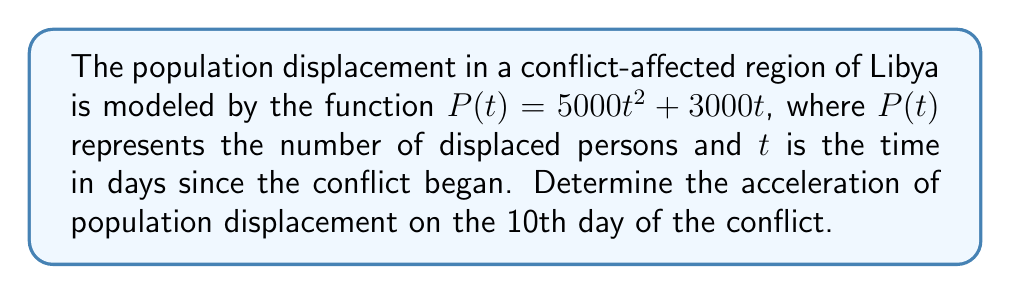Teach me how to tackle this problem. To find the acceleration of population displacement, we need to calculate the second derivative of the given function $P(t)$.

Step 1: Find the first derivative (velocity of displacement)
The first derivative represents the rate of change of displacement with respect to time:
$$P'(t) = \frac{d}{dt}(5000t^2 + 3000t) = 10000t + 3000$$

Step 2: Find the second derivative (acceleration of displacement)
The second derivative represents the rate of change of velocity with respect to time:
$$P''(t) = \frac{d}{dt}(10000t + 3000) = 10000$$

Step 3: Evaluate the acceleration at t = 10
Since the second derivative is constant, the acceleration is the same for all values of t, including t = 10:
$$P''(10) = 10000$$

Therefore, the acceleration of population displacement on the 10th day of the conflict is 10,000 persons per day squared.
Answer: 10,000 persons/day² 